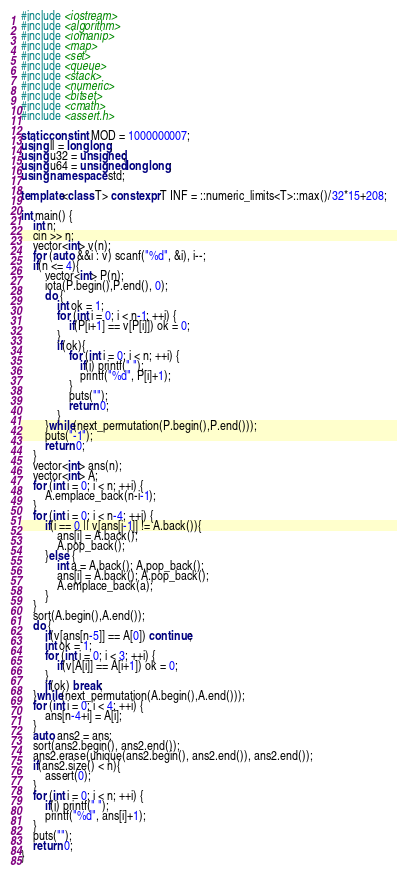<code> <loc_0><loc_0><loc_500><loc_500><_C++_>#include <iostream>
#include <algorithm>
#include <iomanip>
#include <map>
#include <set>
#include <queue>
#include <stack>
#include <numeric>
#include <bitset>
#include <cmath>
#include <assert.h>

static const int MOD = 1000000007;
using ll = long long;
using u32 = unsigned;
using u64 = unsigned long long;
using namespace std;

template<class T> constexpr T INF = ::numeric_limits<T>::max()/32*15+208;

int main() {
    int n;
    cin >> n;
    vector<int> v(n);
    for (auto &&i : v) scanf("%d", &i), i--;
    if(n <= 4){
        vector<int> P(n);
        iota(P.begin(),P.end(), 0);
        do {
            int ok = 1;
            for (int i = 0; i < n-1; ++i) {
                if(P[i+1] == v[P[i]]) ok = 0;
            }
            if(ok){
                for (int i = 0; i < n; ++i) {
                    if(i) printf(" ");
                    printf("%d", P[i]+1);
                }
                puts("");
                return 0;
            }
        }while(next_permutation(P.begin(),P.end()));
        puts("-1");
        return 0;
    }
    vector<int> ans(n);
    vector<int> A;
    for (int i = 0; i < n; ++i) {
        A.emplace_back(n-i-1);
    }
    for (int i = 0; i < n-4; ++i) {
        if(i == 0 || v[ans[i-1]] != A.back()){
            ans[i] = A.back();
            A.pop_back();
        }else {
            int a = A.back(); A.pop_back();
            ans[i] = A.back(); A.pop_back();
            A.emplace_back(a);
        }
    }
    sort(A.begin(),A.end());
    do {
        if(v[ans[n-5]] == A[0]) continue;
        int ok = 1;
        for (int i = 0; i < 3; ++i) {
            if(v[A[i]] == A[i+1]) ok = 0;
        }
        if(ok) break;
    }while(next_permutation(A.begin(),A.end()));
    for (int i = 0; i < 4; ++i) {
        ans[n-4+i] = A[i];
    }
    auto ans2 = ans;
    sort(ans2.begin(), ans2.end());
    ans2.erase(unique(ans2.begin(), ans2.end()), ans2.end());
    if(ans2.size() < n){
        assert(0);
    }
    for (int i = 0; i < n; ++i) {
        if(i) printf(" ");
        printf("%d", ans[i]+1);
    }
    puts("");
    return 0;
}</code> 